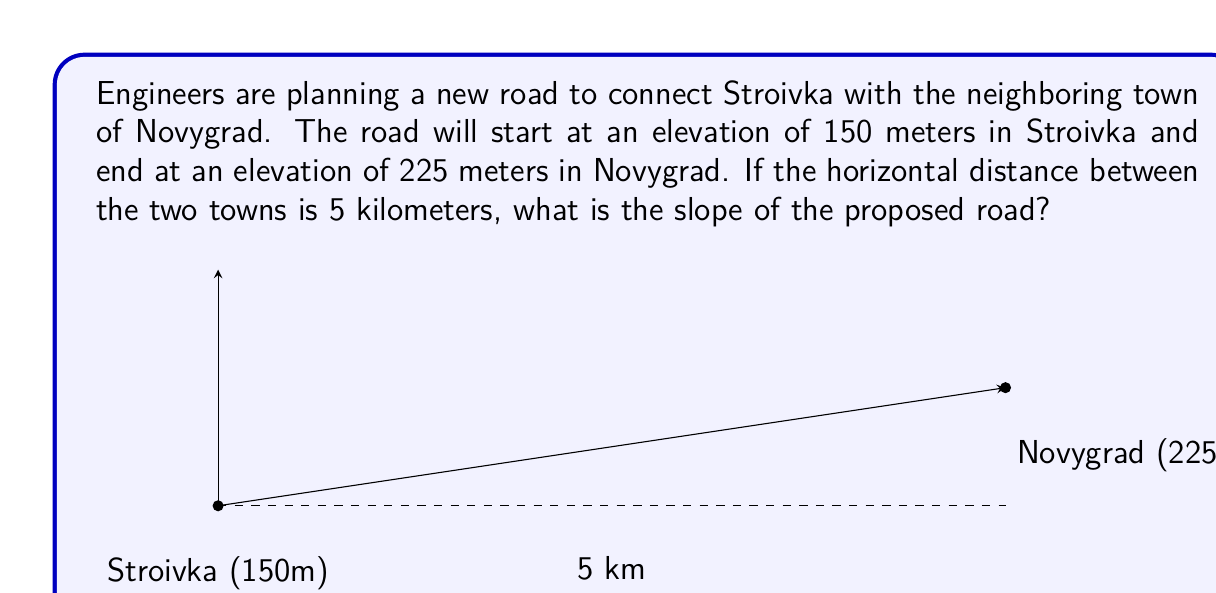Can you solve this math problem? Let's approach this step-by-step:

1) First, recall that slope is defined as the change in vertical distance (rise) divided by the change in horizontal distance (run):

   $$ \text{Slope} = \frac{\text{Rise}}{\text{Run}} $$

2) In this problem:
   - Rise = Change in elevation = 225 m - 150 m = 75 m
   - Run = Horizontal distance = 5 km = 5000 m

3) Let's substitute these values into our slope formula:

   $$ \text{Slope} = \frac{75 \text{ m}}{5000 \text{ m}} $$

4) Simplify the fraction:

   $$ \text{Slope} = \frac{3}{200} = 0.015 $$

5) To express this as a percentage, multiply by 100:

   $$ \text{Slope} = 0.015 \times 100 = 1.5\% $$

This means the road rises 1.5 meters for every 100 meters of horizontal distance.
Answer: 1.5% or 0.015 